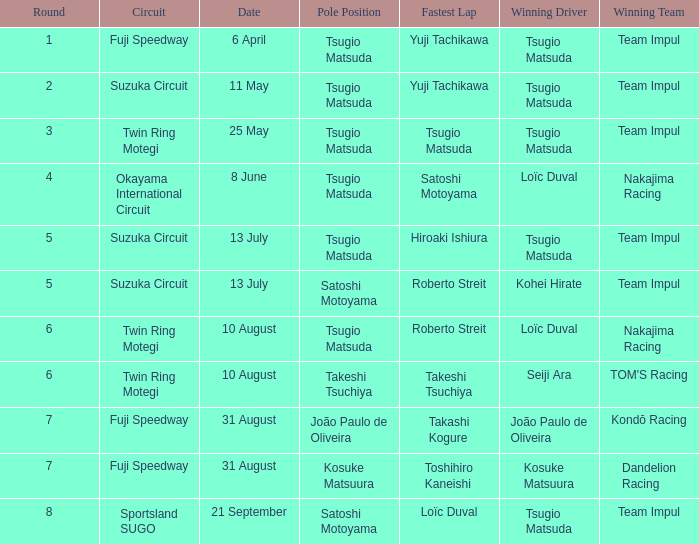On what date does Yuji Tachikawa have the fastest lap in round 1? 6 April. 